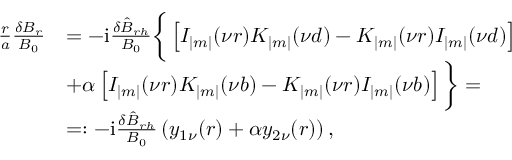<formula> <loc_0><loc_0><loc_500><loc_500>\begin{array} { r } { \begin{array} { r l } { \frac { r } { a } \frac { \delta B _ { r } } { B _ { 0 } } } & { = - i \frac { \delta \hat { B } _ { r h } } { B _ { 0 } } \left \{ \left [ I _ { | m | } ( \nu r ) K _ { | m | } ( \nu d ) - K _ { | m | } ( \nu r ) I _ { | m | } ( \nu d ) \right ] } \\ & { + \alpha \left [ I _ { | m | } ( \nu r ) K _ { | m | } ( \nu b ) - K _ { | m | } ( \nu r ) I _ { | m | } ( \nu b ) \right ] \right \} = } \\ & { = \colon - i \frac { \delta \hat { B } _ { r h } } { B _ { 0 } } \left ( y _ { 1 \nu } ( r ) + \alpha y _ { 2 \nu } ( r ) \right ) , } \end{array} } \end{array}</formula> 